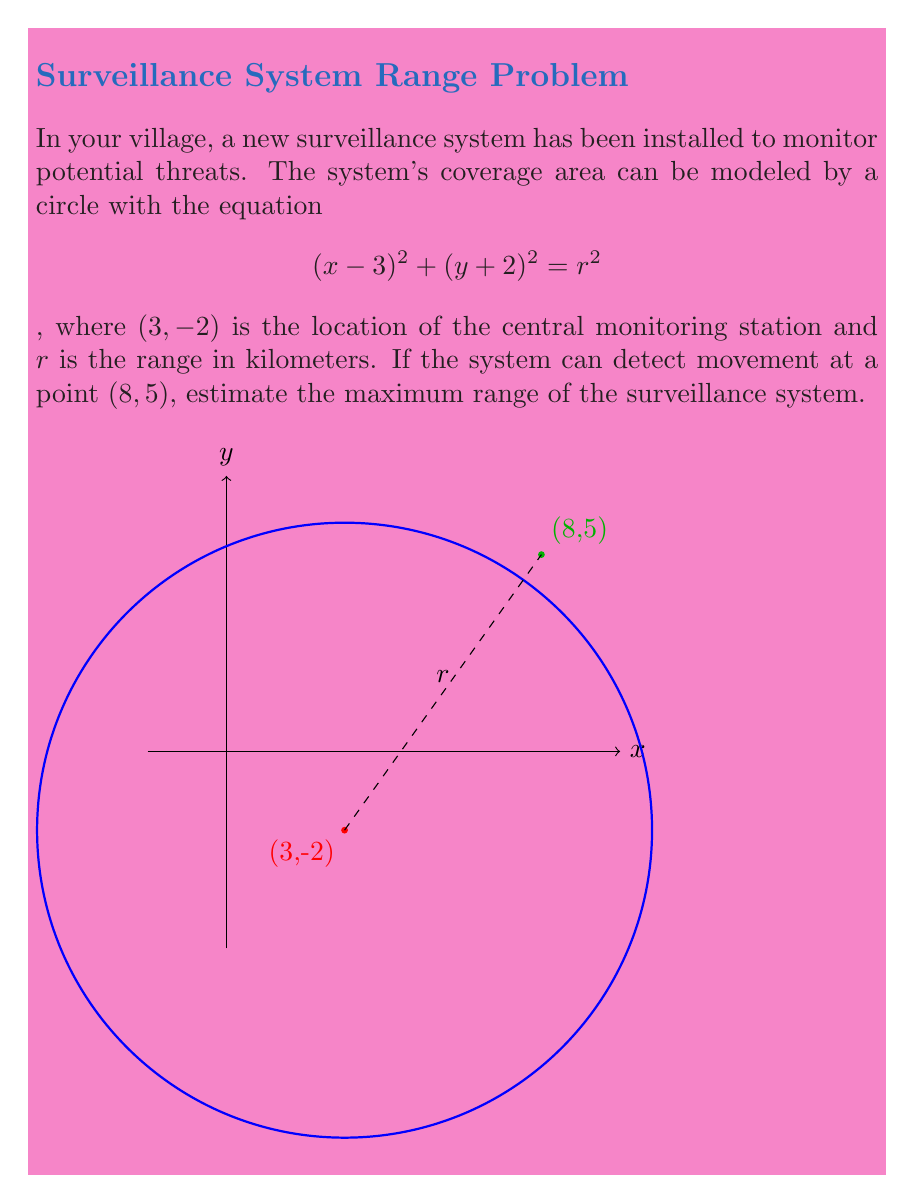Can you solve this math problem? To solve this problem, we'll follow these steps:

1) The general equation of a circle is $(x-h)^2 + (y-k)^2 = r^2$, where $(h,k)$ is the center and $r$ is the radius.

2) In this case, the center is at $(3,-2)$, which matches our equation $(x-3)^2 + (y+2)^2 = r^2$.

3) To find $r$, we need to calculate the distance between the center $(3,-2)$ and the point $(8,5)$ that the system can detect.

4) We can use the distance formula:
   $$r = \sqrt{(x_2-x_1)^2 + (y_2-y_1)^2}$$

5) Plugging in our points:
   $$r = \sqrt{(8-3)^2 + (5-(-2))^2}$$

6) Simplify:
   $$r = \sqrt{5^2 + 7^2} = \sqrt{25 + 49} = \sqrt{74}$$

7) Calculate the square root:
   $$r \approx 8.60 \text{ km}$$

Therefore, the maximum range of the surveillance system is approximately 8.60 kilometers.
Answer: $8.60 \text{ km}$ 